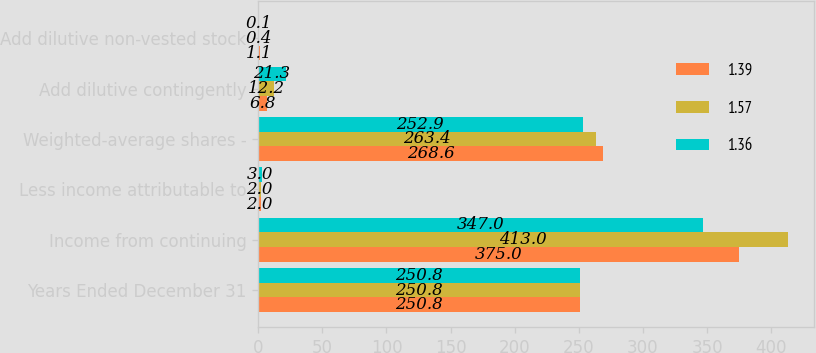<chart> <loc_0><loc_0><loc_500><loc_500><stacked_bar_chart><ecel><fcel>Years Ended December 31<fcel>Income from continuing<fcel>Less income attributable to<fcel>Weighted-average shares -<fcel>Add dilutive contingently<fcel>Add dilutive non-vested stock<nl><fcel>1.39<fcel>250.8<fcel>375<fcel>2<fcel>268.6<fcel>6.8<fcel>1.1<nl><fcel>1.57<fcel>250.8<fcel>413<fcel>2<fcel>263.4<fcel>12.2<fcel>0.4<nl><fcel>1.36<fcel>250.8<fcel>347<fcel>3<fcel>252.9<fcel>21.3<fcel>0.1<nl></chart> 